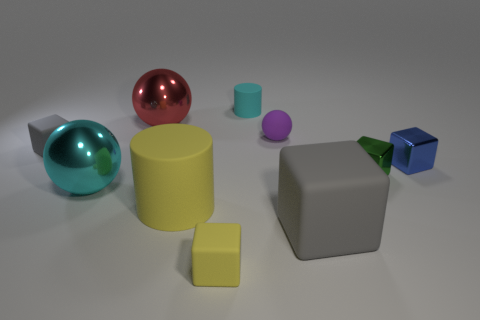What material is the cyan thing left of the tiny matte thing that is in front of the big rubber object on the left side of the cyan cylinder?
Offer a terse response. Metal. The yellow cylinder that is the same material as the tiny yellow object is what size?
Give a very brief answer. Large. The red thing is what shape?
Your response must be concise. Sphere. Do the small gray thing and the cyan thing that is left of the small yellow cube have the same material?
Your answer should be compact. No. What is the shape of the small thing that is in front of the yellow object that is behind the small yellow object?
Give a very brief answer. Cube. How many objects are metallic blocks that are in front of the blue shiny block or objects behind the tiny yellow rubber block?
Your response must be concise. 9. There is a yellow thing that is the same size as the cyan cylinder; what is it made of?
Your answer should be very brief. Rubber. The big rubber cylinder has what color?
Your response must be concise. Yellow. There is a ball that is on the left side of the tiny cyan cylinder and in front of the big red thing; what is it made of?
Provide a succinct answer. Metal. Are there any big cylinders in front of the matte cube in front of the gray matte object that is right of the purple rubber object?
Your answer should be compact. No. 